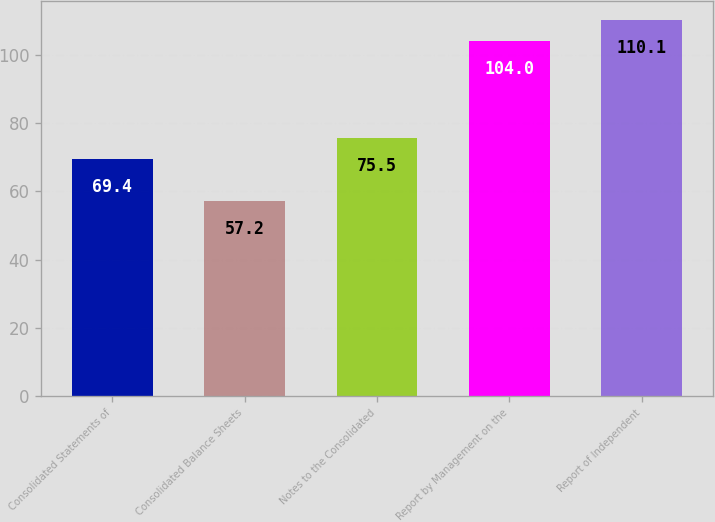Convert chart. <chart><loc_0><loc_0><loc_500><loc_500><bar_chart><fcel>Consolidated Statements of<fcel>Consolidated Balance Sheets<fcel>Notes to the Consolidated<fcel>Report by Management on the<fcel>Report of Independent<nl><fcel>69.4<fcel>57.2<fcel>75.5<fcel>104<fcel>110.1<nl></chart> 